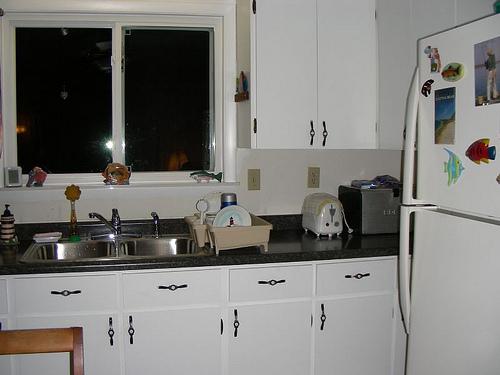What kitchen appliance is beside the sink and counter?
Write a very short answer. Toaster. Is the window open?
Be succinct. No. Are there any plants on the sink?
Give a very brief answer. No. Is there a plant on the window sill?
Short answer required. No. Where is the hand soap?
Keep it brief. Counter. What room is this?
Be succinct. Kitchen. Which side of the picture has the fridge?
Quick response, please. Right. Have all of the dishes been washed and put away?
Concise answer only. No. What brand is the toaster?
Be succinct. Oster. 